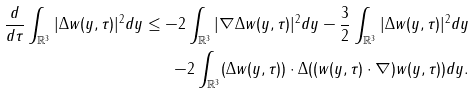<formula> <loc_0><loc_0><loc_500><loc_500>\frac { d } { d \tau } \int _ { \mathbb { R } ^ { 3 } } | \Delta w ( y , \tau ) | ^ { 2 } d y \leq - 2 \int _ { \mathbb { R } ^ { 3 } } | \nabla \Delta w ( y , \tau ) | ^ { 2 } d y - \frac { 3 } { 2 } \int _ { \mathbb { R } ^ { 3 } } | \Delta w ( y , \tau ) | ^ { 2 } d y \\ - 2 \int _ { \mathbb { R } ^ { 3 } } ( \Delta w ( y , \tau ) ) \cdot \Delta ( ( w ( y , \tau ) \cdot \nabla ) w ( y , \tau ) ) d y .</formula> 